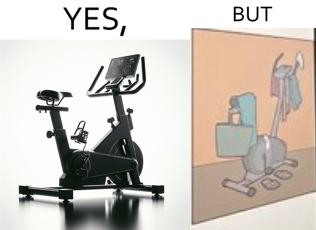Does this image contain satire or humor? Yes, this image is satirical. 